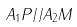<formula> <loc_0><loc_0><loc_500><loc_500>A _ { 1 } P / / A _ { 2 } M</formula> 